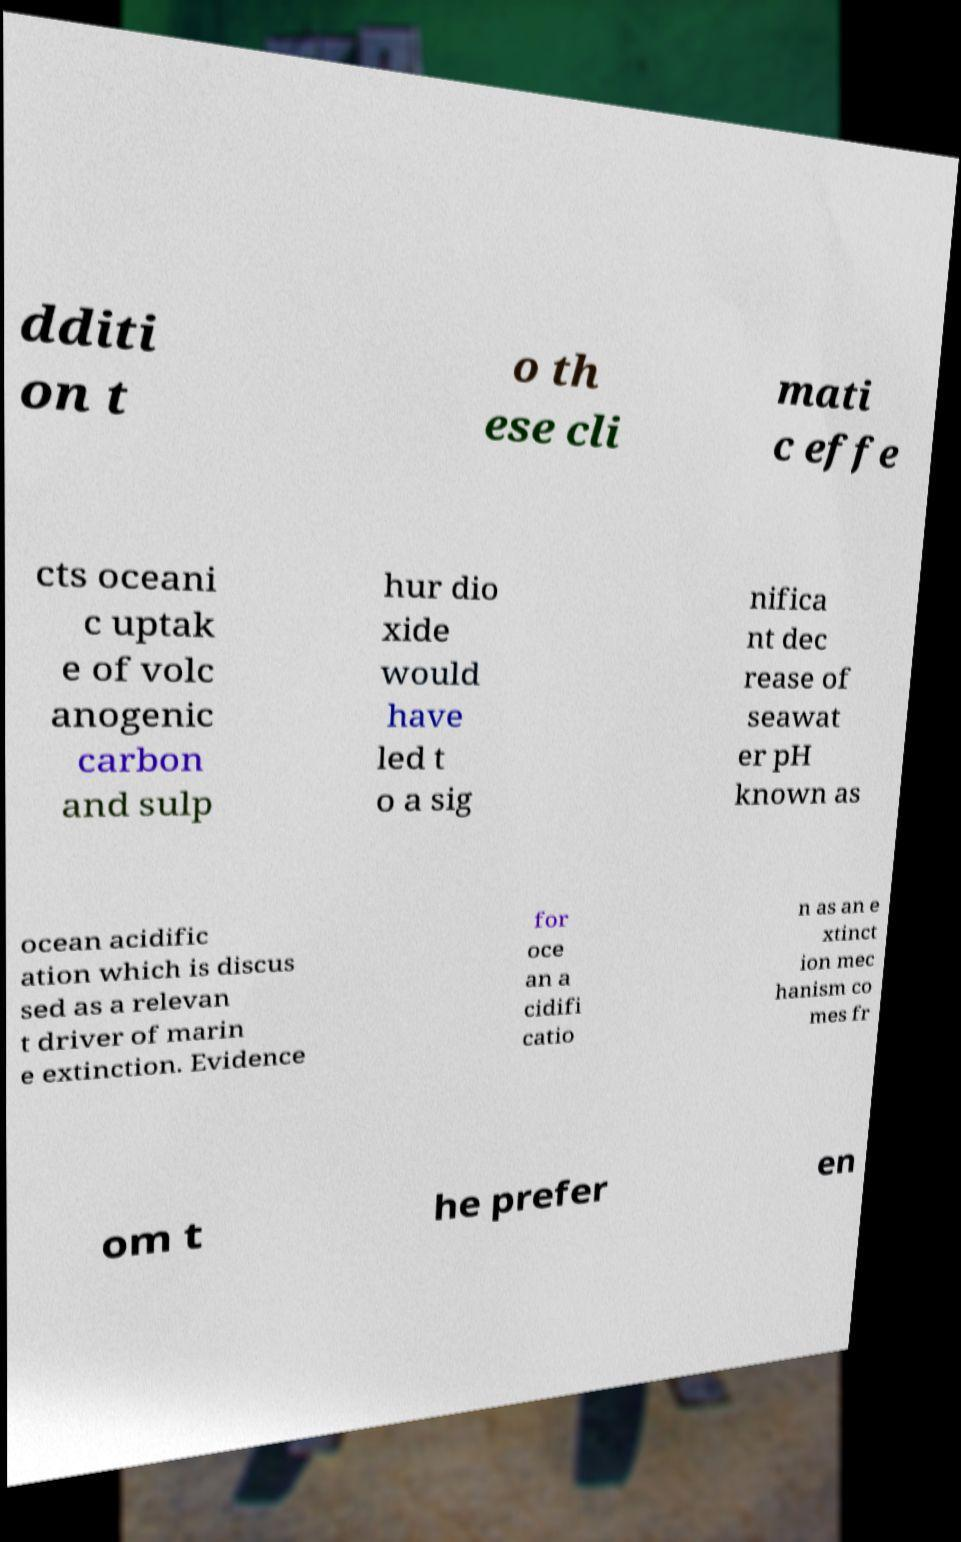Could you extract and type out the text from this image? dditi on t o th ese cli mati c effe cts oceani c uptak e of volc anogenic carbon and sulp hur dio xide would have led t o a sig nifica nt dec rease of seawat er pH known as ocean acidific ation which is discus sed as a relevan t driver of marin e extinction. Evidence for oce an a cidifi catio n as an e xtinct ion mec hanism co mes fr om t he prefer en 